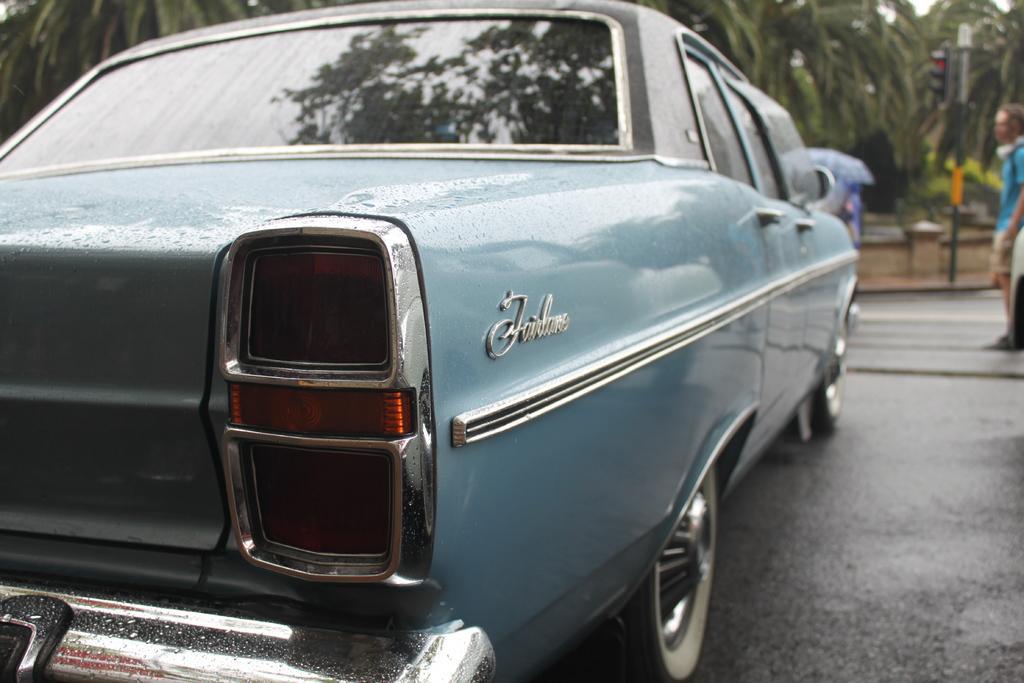Please provide a concise description of this image. In this image we can see a vehicle which is in blue color and there is some text on it. We can see a person standing on the right side of the image and we can see the traffic lights and some trees in the background. 